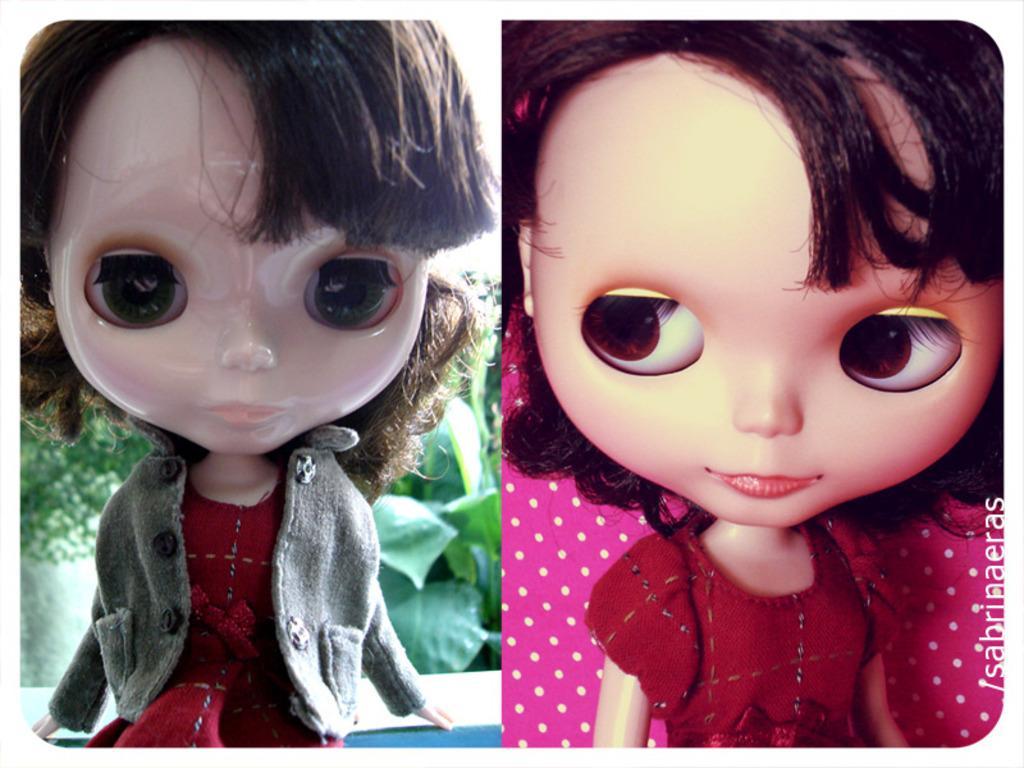Could you give a brief overview of what you see in this image? This is an edited image. On the right we can see a doll wearing red color dress and the background is pink in color. On the left we can see another doll wearing red color dress and jacket and seems to be sitting on an object. In the background we can see the green leaves and we can see the text on the image. 